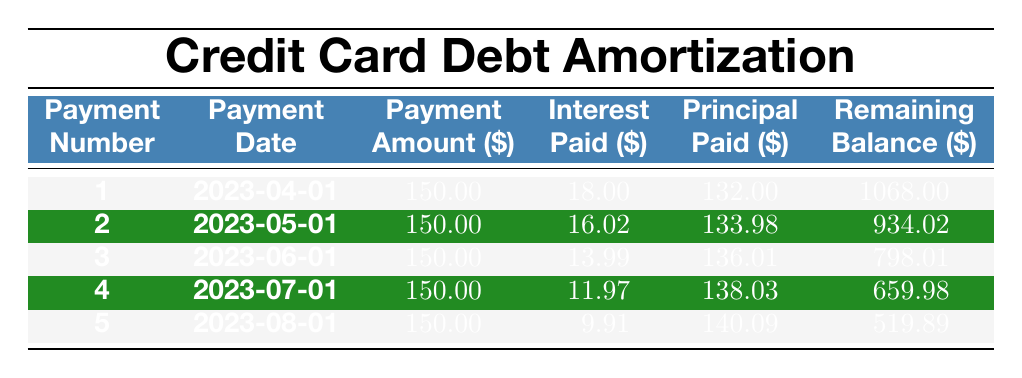What is the remaining balance after the first payment? The first payment was made on April 1, 2023, with a remaining balance recorded as 1068.00.
Answer: 1068.00 How much interest was paid in the second payment? Referring to the second row of the table, the interest paid in the second payment (May 1, 2023) is 16.02.
Answer: 16.02 What is the total amount of principal paid across all five payments? To find the total principal paid, we sum the principal values: 132.00 + 133.98 + 136.01 + 138.03 + 140.09 = 680.11.
Answer: 680.11 Is the interest paid decreasing with each payment? Observing the interest paid column, we see the values decrease from 18.00 to 9.91, confirming that the interest paid is indeed decreasing.
Answer: Yes What was the payment date of the fourth payment? The fourth payment was made on July 1, 2023, as indicated in the table.
Answer: July 1, 2023 What was the average principal paid per month for the payments listed? The total principal paid is 680.11, and since there are 5 payments, we calculate the average as 680.11 / 5 = 136.02.
Answer: 136.02 How will much of the last payment go towards interest? For the last payment, made on August 1, 2023, the interest paid is reported as 9.91, indicating that a smaller portion goes towards interest in comparison to earlier payments.
Answer: 9.91 What is the monthly payment amount? By referring to the table, it shows that the monthly payment amount is consistently 150.00.
Answer: 150.00 How much was the balance reduced from the second payment to the third payment? The remaining balance after the second payment is 934.02 and after the third payment is 798.01. The reduction is 934.02 - 798.01 = 136.01.
Answer: 136.01 